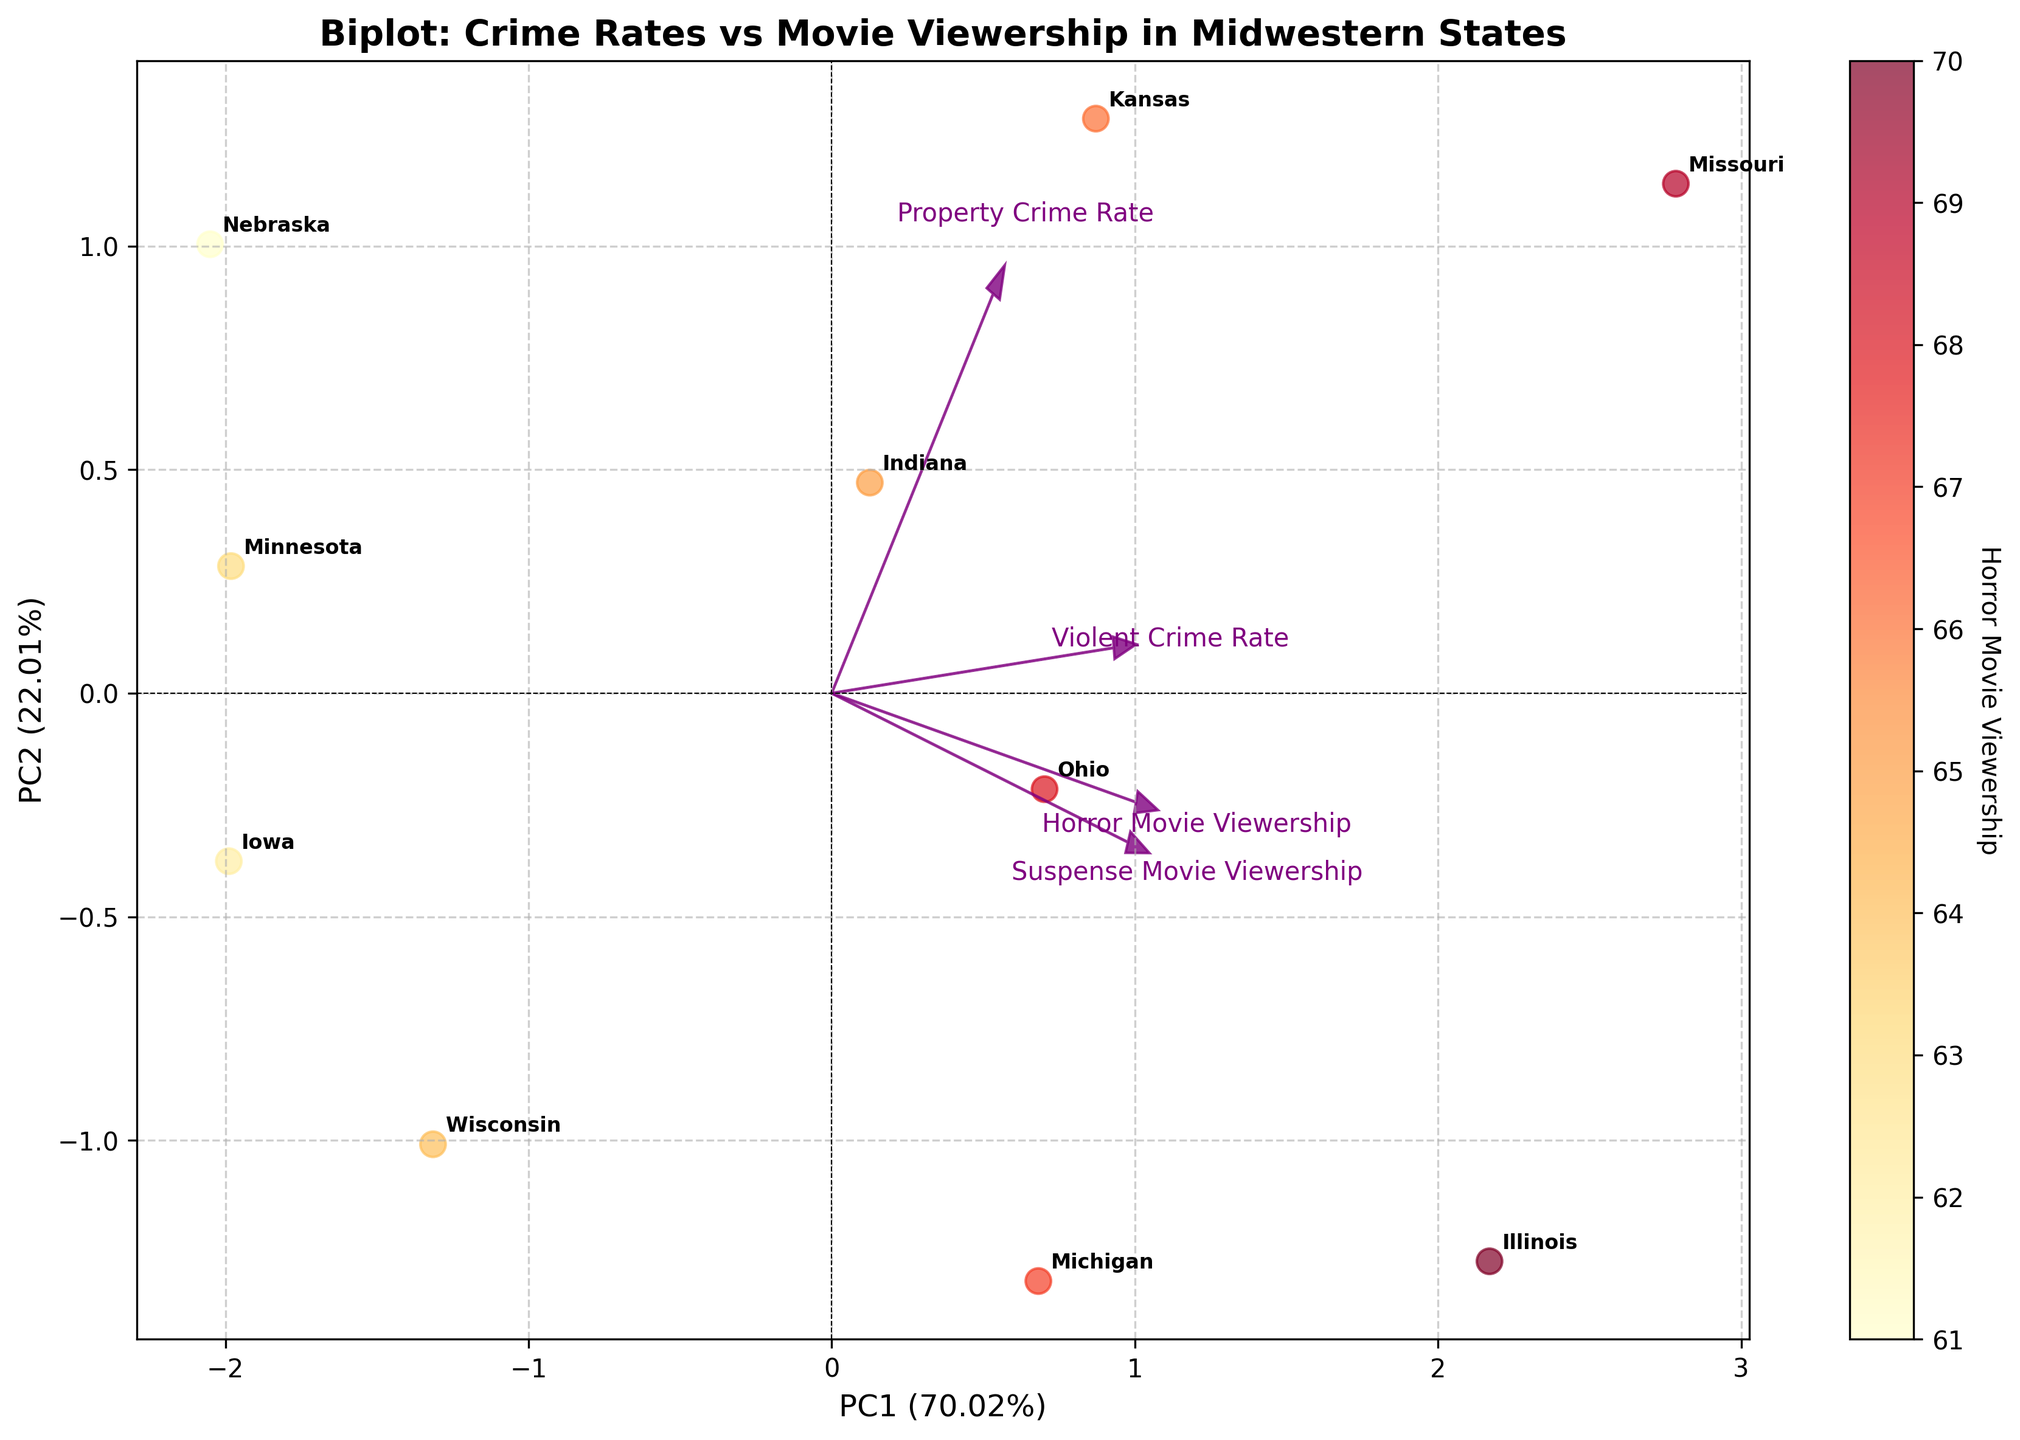what's the title of the plot? To find the title, we need to look at the text at the top of the figure. In this plot, the title is displayed prominently in bold.
Answer: Biplot: Crime Rates vs Movie Viewership in Midwestern States How many states are represented in the plot? The number of states can be counted from the number of state labels present in the plot. Observing the figure, each state is annotated at least once. Counting these annotations gives us the total number of states.
Answer: 10 Which state has the highest violent crime rate and how can you tell? Identifying the state with the highest violent crime rate requires looking at the position corresponding to high values of the "Violent Crime Rate" feature vector in the plot. The state nearest to this vector is the one with the highest value. Missouri is closest to the "Violent Crime Rate" vector.
Answer: Missouri What's the range of the first principal component (PC1) on the x-axis? To determine the range, observe the minimum and maximum values marked on the x-axis. These values denote the range of PC1. The plot shows PC1 values ranging from approximately -2.5 to 3.0.
Answer: -2.5 to 3.0 Which feature has the longest vector in the plot? The feature with the longest vector can be identified by looking at the arrows representing loadings. The length of these arrows indicates the strength of the correlation. "Violent Crime Rate" appears to have the longest arrow.
Answer: Violent Crime Rate Which state shows a relatively high viewership of suspense movies but low violent crime rate? A state fitting this criterion will be located near the "Suspense Movie Viewership" vector but further from the "Violent Crime Rate" vector. By observing the plot, Iowa seems to fit this description.
Answer: Iowa What can you infer about the relationship between property crime rate and horror movie viewership? To infer the relationship, observe the direction and relative angle between the "Property Crime Rate" and "Horror Movie Viewership" vectors. Angles closer to zero suggest a positive correlation, and near 180 degrees indicate a negative correlation. These vectors are somewhat aligned, indicating a moderate positive correlation.
Answer: Moderate positive correlation Are there states clustered together with similar crime rates or movie viewership? Clusters of states can be noticed by observing states that are closely packed in the principal component space. Illinois, Indiana, and Kansas appear close to one another, suggesting similar characteristics.
Answer: Illinois, Indiana, Kansas Which principal component (PC1 or PC2) explains more variance, and by how much? The variance explained by each component is indicated on the respective axis labels. PC1 explains more variance than PC2, with the exact percentage given next to each axis. PC1 explains 57% and PC2 explains 22%.
Answer: PC1 by 35% Is Ohio more associated with higher property crime rate or violent crime rate, and how do you know? To determine this, find Ohio's position relative to the "Property Crime Rate" and "Violent Crime Rate" vectors. Ohio is closer to the "Property Crime Rate" vector than to "Violent Crime Rate."
Answer: Higher property crime rate 